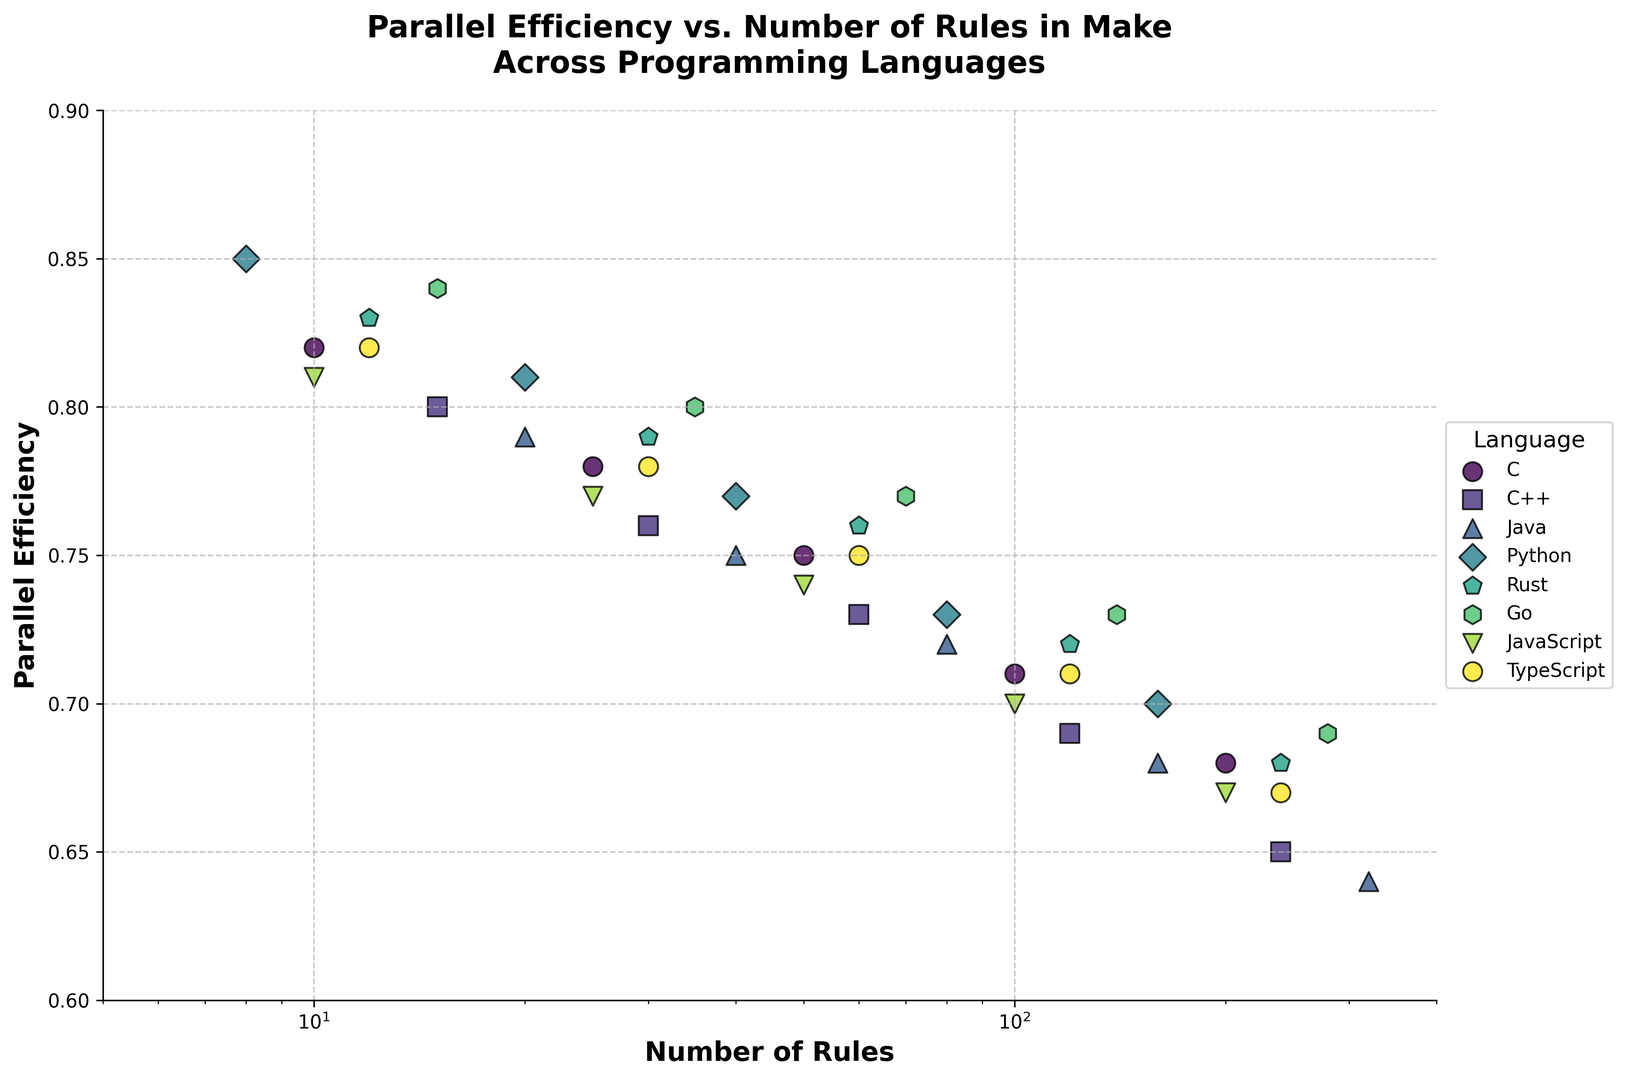What's the parallel efficiency for Java with 160 rules? Look for the data point corresponding to Java with 160 rules and note the parallel efficiency.
Answer: 0.68 Which language maintains the highest parallel efficiency at the lowest number of rules? Identify the data points with the smallest number of rules for each language, then compare their parallel efficiencies to find the highest one.
Answer: Python How does the parallel efficiency for C change as the number of rules increases from 10 to 200? Observe the change in parallel efficiency for C from 10 rules (0.82) to 200 rules (0.68) by noting the values at those points.
Answer: It decreases On average, which language shows the highest parallel efficiency across all rule counts? Calculate the average parallel efficiency for each language across all rule counts and compare them. Python: (0.85 + 0.81 + 0.77 + 0.73 + 0.70) / 5
Answer: Python Is there a language that consistently maintains at least 0.75 efficiency across all rule counts? Examine the parallel efficiencies for all rule counts of each language and check if any language consistently stays at or above 0.75.
Answer: No Which language shows the steepest decline in parallel efficiency as the number of rules increases? Compare the parallel efficiencies at the smallest and largest number of rules for each language, calculate the difference, and find the steepest decline.
Answer: Java Which language's parallel efficiency is closest to 0.70 with 120 rules? Find the data points where the number of rules is 120 and identify which language's parallel efficiency is closest to 0.70.
Answer: Python Compare the parallel efficiencies between C++ and Rust at 60 rules. Which one is higher? Identify the parallel efficiencies for C++ (0.73) and Rust (0.76) at 60 rules, and compare them.
Answer: Rust At around 50 rules, which language shows parallel efficiency closest to 0.75? For the data points near 50 rules (C, C++, JavaScript, TypeScript), check which one has a parallel efficiency closest to 0.75.
Answer: TypeScript Identify the visual markers used for Python and JavaScript. Look at the shape and color of the markers used to plot data points for Python and JavaScript.
Answer: Python: Circle, JavaScript: Diamond 